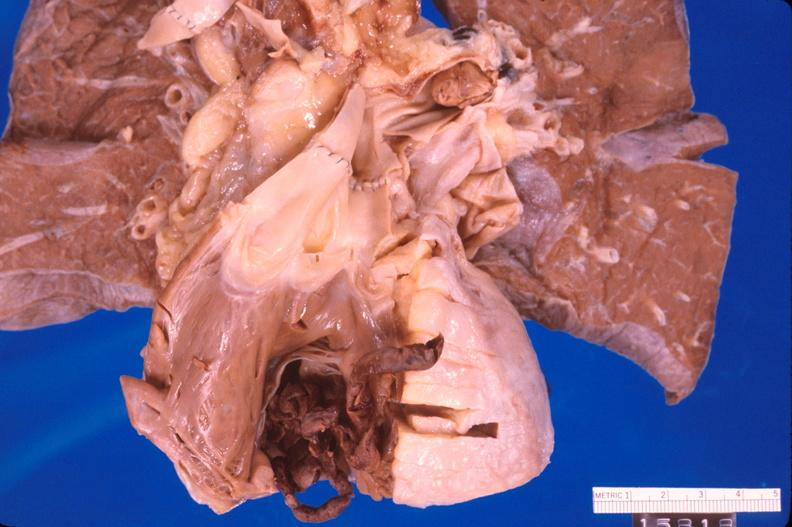what is present?
Answer the question using a single word or phrase. Cardiovascular 